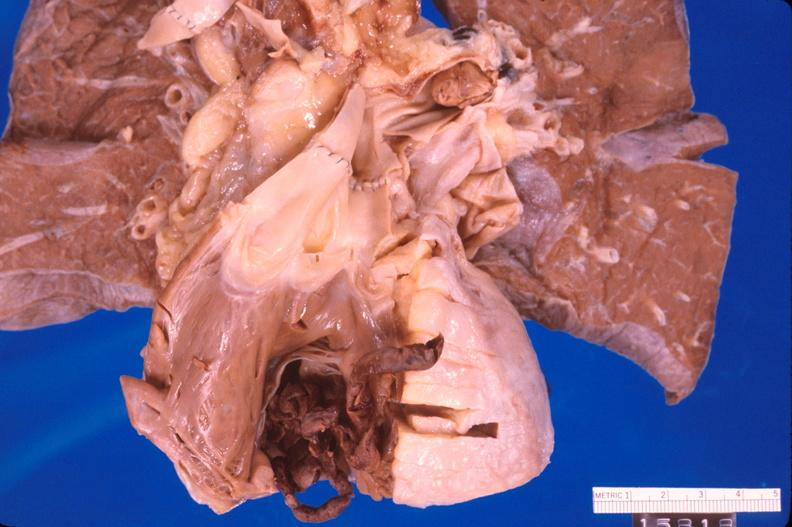what is present?
Answer the question using a single word or phrase. Cardiovascular 